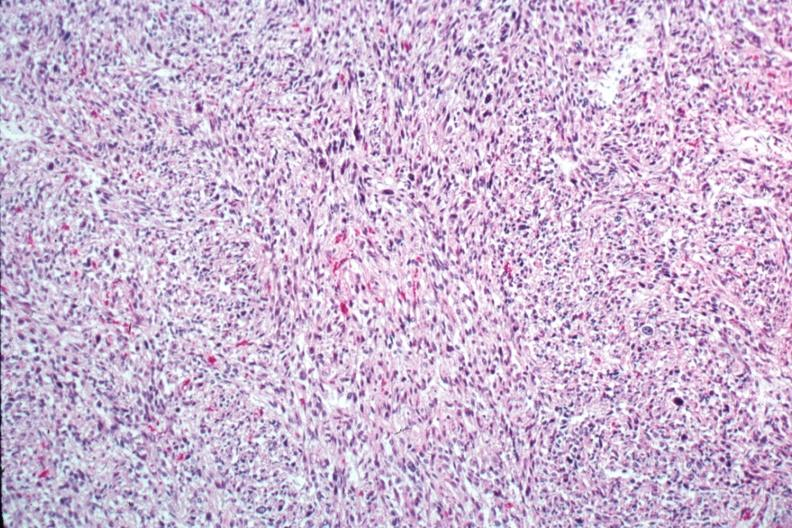s 70yof present?
Answer the question using a single word or phrase. No 